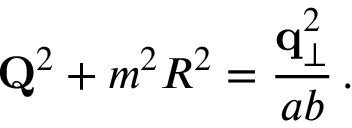Convert formula to latex. <formula><loc_0><loc_0><loc_500><loc_500>{ Q } ^ { 2 } + m ^ { 2 } R ^ { 2 } = { \frac { { q } _ { \perp } ^ { 2 } } { a b } } \, .</formula> 